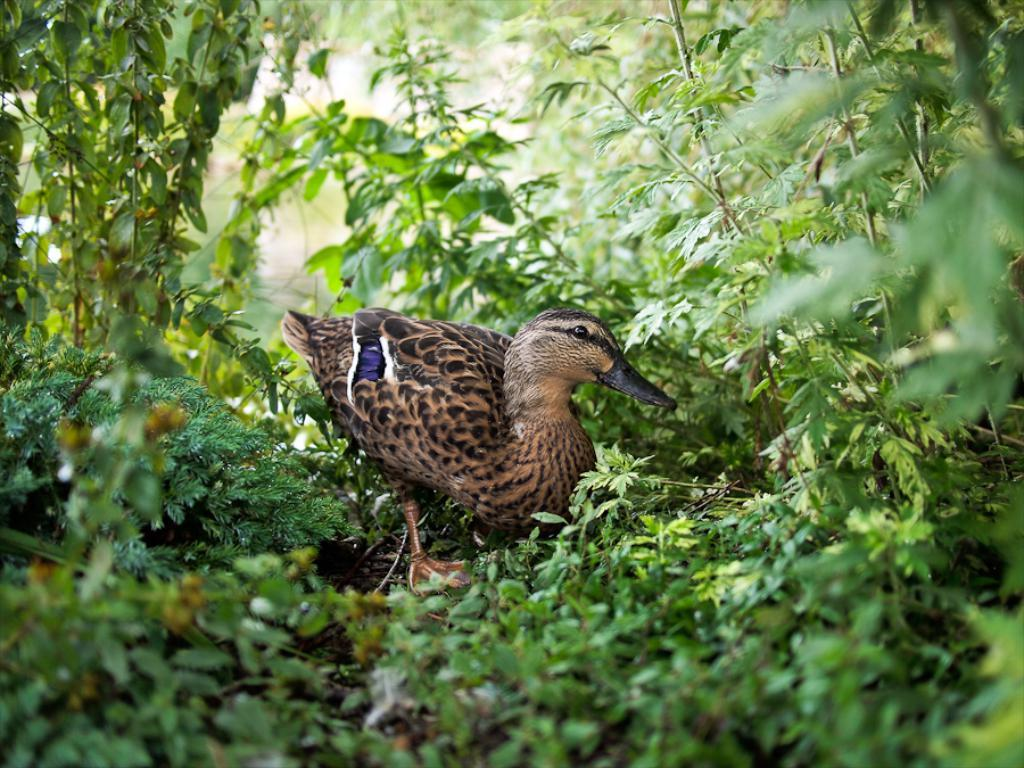What type of animal is in the image? There is a bird in the image. Can you describe the bird's coloring? The bird has brown, black, and violet coloring. What type of vegetation is present in the image? There are green leaves on stems in the image. What type of apparatus is the bird using to fly in the image? There is no apparatus present in the image; the bird is flying using its own wings. 